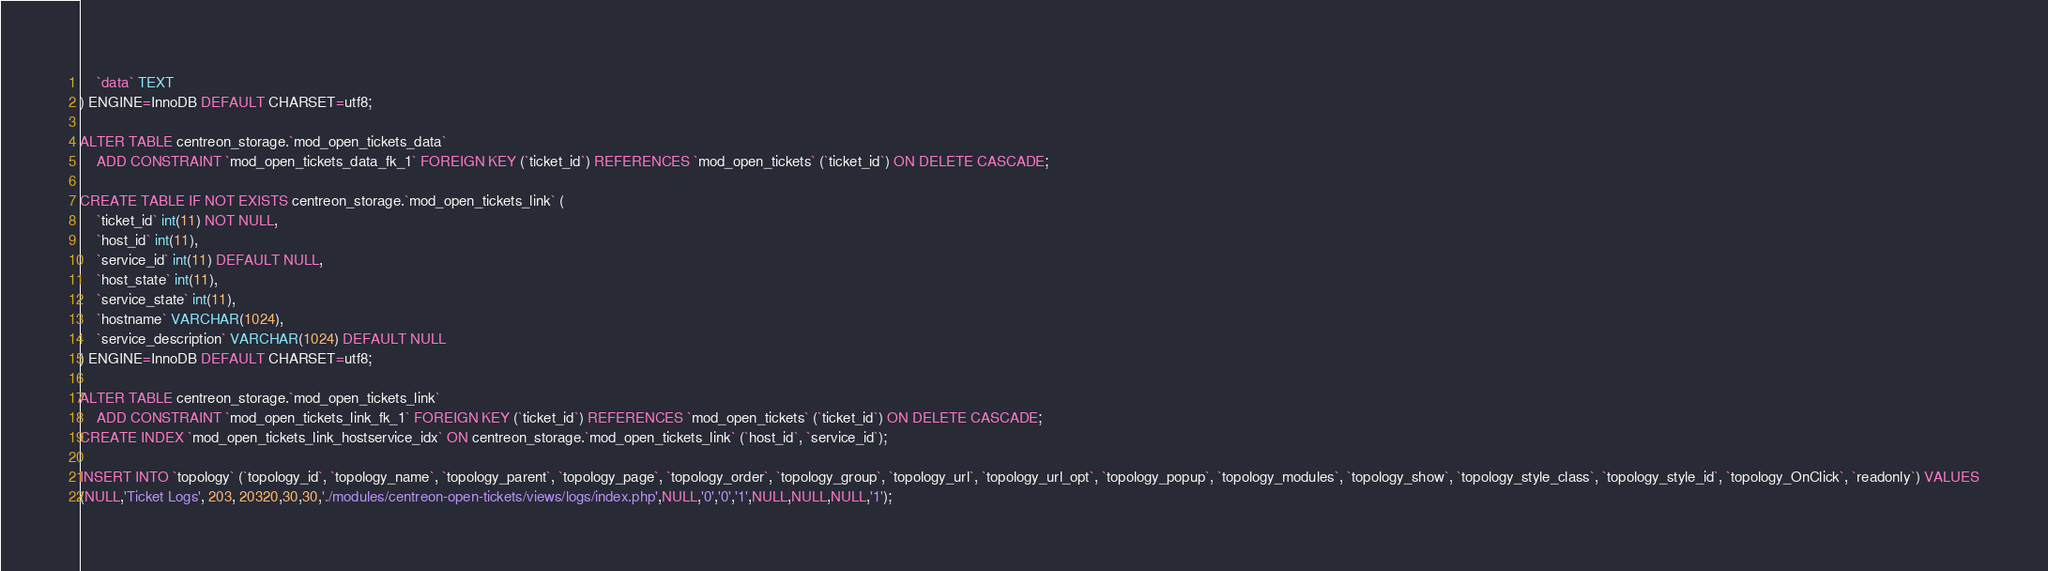<code> <loc_0><loc_0><loc_500><loc_500><_SQL_>    `data` TEXT
) ENGINE=InnoDB DEFAULT CHARSET=utf8;

ALTER TABLE centreon_storage.`mod_open_tickets_data`
    ADD CONSTRAINT `mod_open_tickets_data_fk_1` FOREIGN KEY (`ticket_id`) REFERENCES `mod_open_tickets` (`ticket_id`) ON DELETE CASCADE;

CREATE TABLE IF NOT EXISTS centreon_storage.`mod_open_tickets_link` (
    `ticket_id` int(11) NOT NULL,
    `host_id` int(11),
    `service_id` int(11) DEFAULT NULL,
    `host_state` int(11),
    `service_state` int(11),
    `hostname` VARCHAR(1024),
    `service_description` VARCHAR(1024) DEFAULT NULL
) ENGINE=InnoDB DEFAULT CHARSET=utf8;

ALTER TABLE centreon_storage.`mod_open_tickets_link`
    ADD CONSTRAINT `mod_open_tickets_link_fk_1` FOREIGN KEY (`ticket_id`) REFERENCES `mod_open_tickets` (`ticket_id`) ON DELETE CASCADE;
CREATE INDEX `mod_open_tickets_link_hostservice_idx` ON centreon_storage.`mod_open_tickets_link` (`host_id`, `service_id`);

INSERT INTO `topology` (`topology_id`, `topology_name`, `topology_parent`, `topology_page`, `topology_order`, `topology_group`, `topology_url`, `topology_url_opt`, `topology_popup`, `topology_modules`, `topology_show`, `topology_style_class`, `topology_style_id`, `topology_OnClick`, `readonly`) VALUES
(NULL,'Ticket Logs', 203, 20320,30,30,'./modules/centreon-open-tickets/views/logs/index.php',NULL,'0','0','1',NULL,NULL,NULL,'1');</code> 